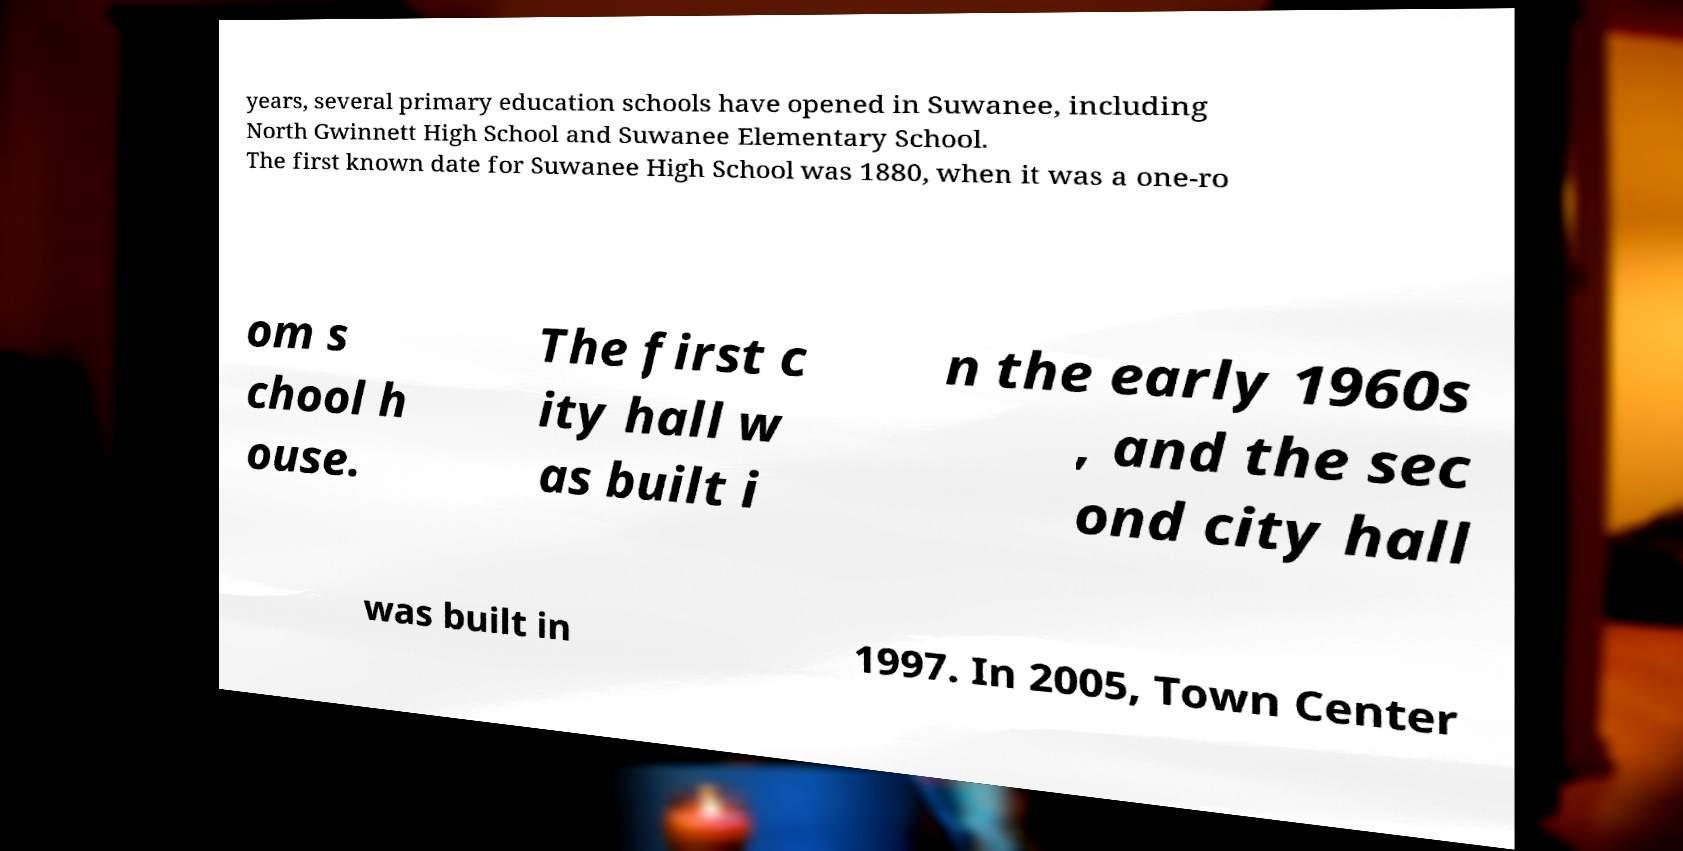What messages or text are displayed in this image? I need them in a readable, typed format. years, several primary education schools have opened in Suwanee, including North Gwinnett High School and Suwanee Elementary School. The first known date for Suwanee High School was 1880, when it was a one-ro om s chool h ouse. The first c ity hall w as built i n the early 1960s , and the sec ond city hall was built in 1997. In 2005, Town Center 